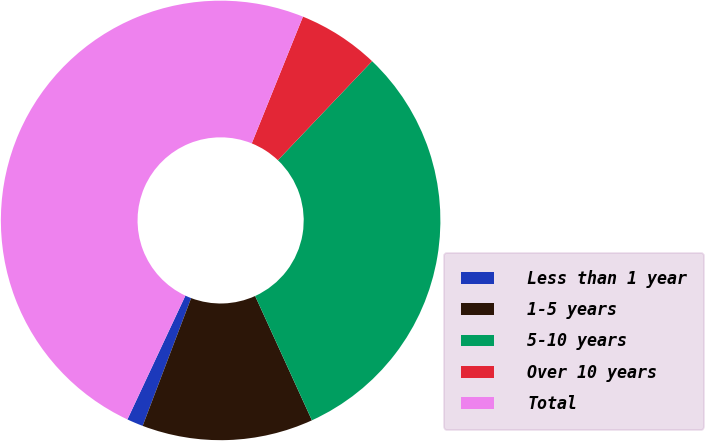<chart> <loc_0><loc_0><loc_500><loc_500><pie_chart><fcel>Less than 1 year<fcel>1-5 years<fcel>5-10 years<fcel>Over 10 years<fcel>Total<nl><fcel>1.2%<fcel>12.59%<fcel>31.08%<fcel>5.99%<fcel>49.14%<nl></chart> 